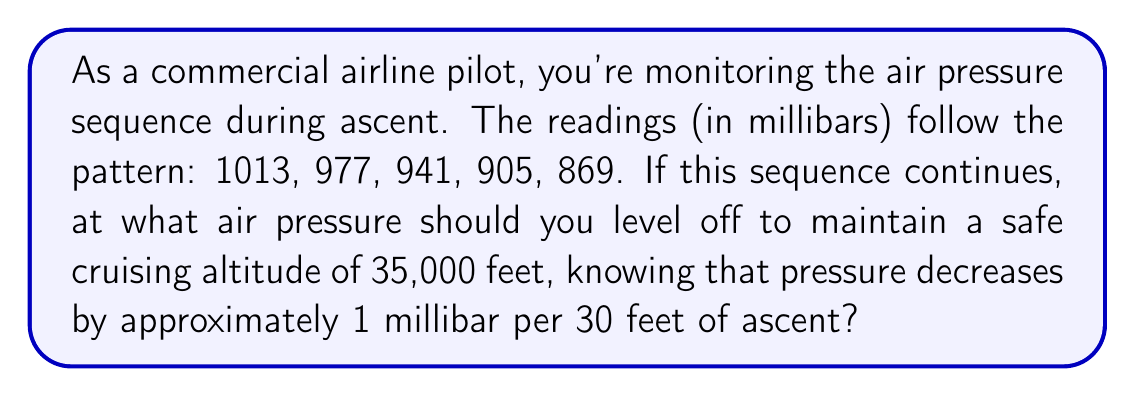Give your solution to this math problem. Let's approach this step-by-step:

1) First, we need to identify the pattern in the given sequence:
   1013, 977, 941, 905, 869
   The difference between each term is 36 millibars.

2) We can express this sequence mathematically as:
   $$a_n = 1013 - 36(n-1)$$
   where $n$ is the term number and $a_n$ is the air pressure at that term.

3) Now, we need to find out how many terms we need to reach 35,000 feet:
   * We know pressure decreases by 1 millibar per 30 feet
   * So, 35,000 feet corresponds to a pressure decrease of:
     $$\frac{35,000}{30} = 1166.67$$ millibars

4) We can set up an equation:
   $$1013 - 36(n-1) = 1013 - 1166.67$$
   $$36(n-1) = 1166.67$$
   $$n-1 = \frac{1166.67}{36} = 32.41$$
   $$n = 33.41$$

5) Since we can't have a fractional term, we round up to be safe:
   $n = 34$

6) Now we can calculate the pressure at this term:
   $$a_{34} = 1013 - 36(34-1) = 1013 - 1188 = -175$$

Therefore, the safe air pressure to level off at is -175 millibars.
Answer: -175 millibars 